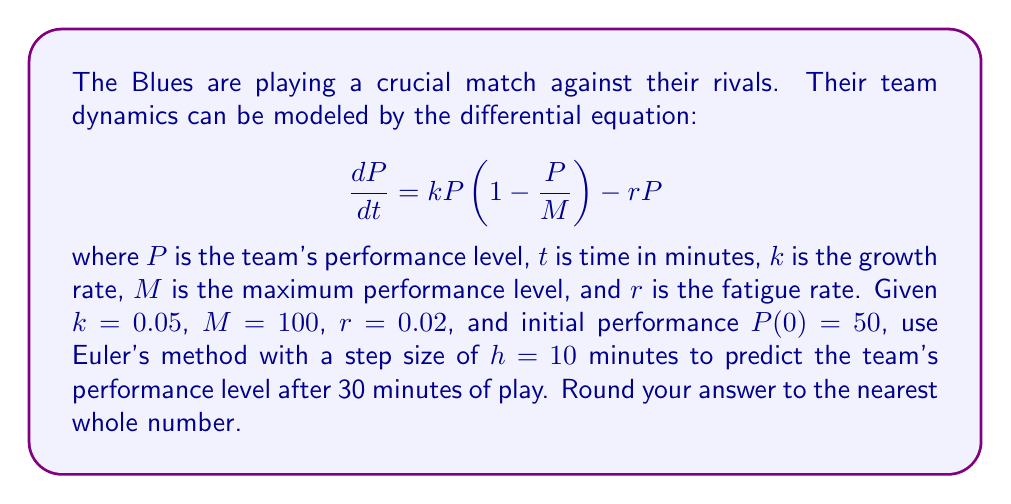Solve this math problem. To solve this problem, we'll use Euler's method to approximate the solution to the differential equation. Euler's method is given by:

$$P_{n+1} = P_n + h \cdot f(t_n, P_n)$$

where $f(t, P) = \frac{dP}{dt} = kP(1-\frac{P}{M}) - rP$

Step 1: Set up the initial values
$P_0 = 50$, $h = 10$, $k = 0.05$, $M = 100$, $r = 0.02$

Step 2: Calculate $P_1$ (after 10 minutes)
$$\begin{align*}
f(0, 50) &= 0.05 \cdot 50 \cdot (1-\frac{50}{100}) - 0.02 \cdot 50 \\
&= 2.5 \cdot 0.5 - 1 = 0.25
\end{align*}$$

$$P_1 = 50 + 10 \cdot 0.25 = 52.5$$

Step 3: Calculate $P_2$ (after 20 minutes)
$$\begin{align*}
f(10, 52.5) &= 0.05 \cdot 52.5 \cdot (1-\frac{52.5}{100}) - 0.02 \cdot 52.5 \\
&= 2.625 \cdot 0.475 - 1.05 = 0.196875
\end{align*}$$

$$P_2 = 52.5 + 10 \cdot 0.196875 = 54.46875$$

Step 4: Calculate $P_3$ (after 30 minutes)
$$\begin{align*}
f(20, 54.46875) &= 0.05 \cdot 54.46875 \cdot (1-\frac{54.46875}{100}) - 0.02 \cdot 54.46875 \\
&= 2.723438 \cdot 0.4553125 - 1.089375 = 0.150586
\end{align*}$$

$$P_3 = 54.46875 + 10 \cdot 0.150586 = 55.97461$$

Step 5: Round to the nearest whole number
55.97461 rounds to 56.
Answer: 56 